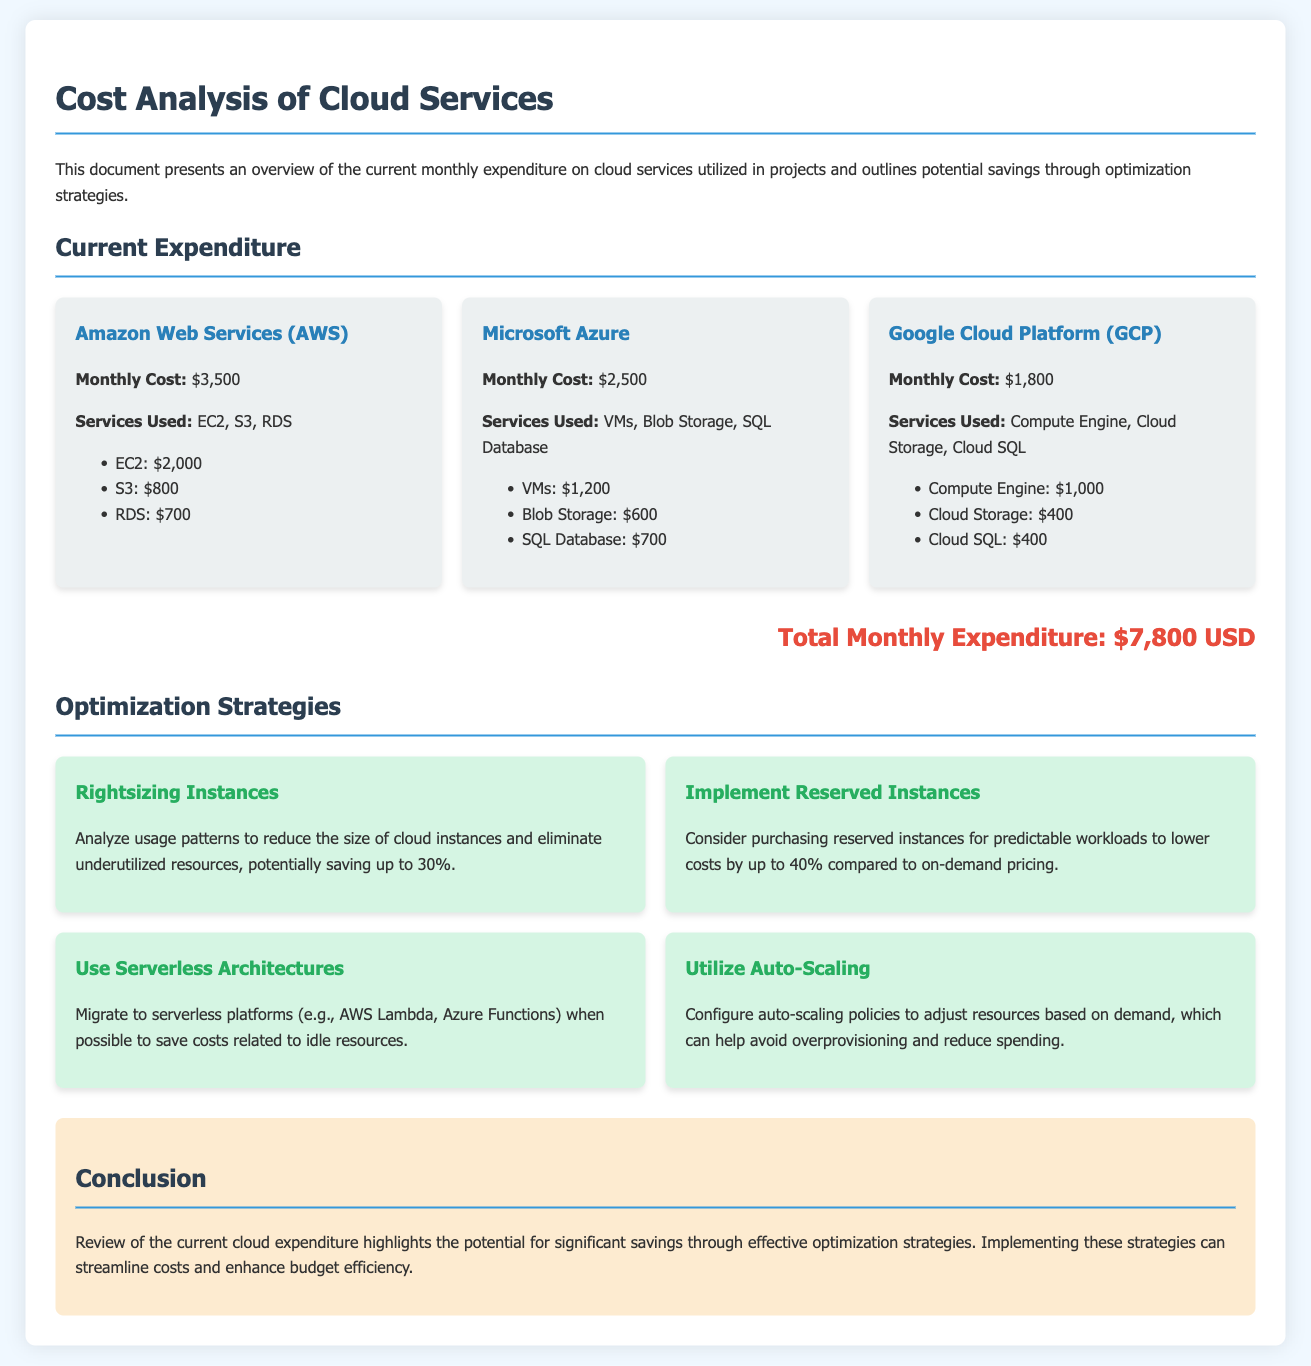What is the total monthly expenditure on cloud services? The total monthly expenditure is explicitly stated in the document, which is $7,800 USD.
Answer: $7,800 USD How much does Amazon Web Services cost per month? The document specifies that the monthly cost for Amazon Web Services (AWS) is $3,500.
Answer: $3,500 What savings potential is mentioned for rightsizing instances? The document notes that rightsizing instances can potentially save up to 30%.
Answer: 30% Which cloud service is associated with $1,800 monthly expenditure? The document identifies Google Cloud Platform (GCP) as having a monthly expenditure of $1,800.
Answer: Google Cloud Platform (GCP) What is a recommended strategy to lower costs by up to 40%? The document suggests implementing reserved instances for predictable workloads as a strategy to lower costs by up to 40%.
Answer: Reserved instances 